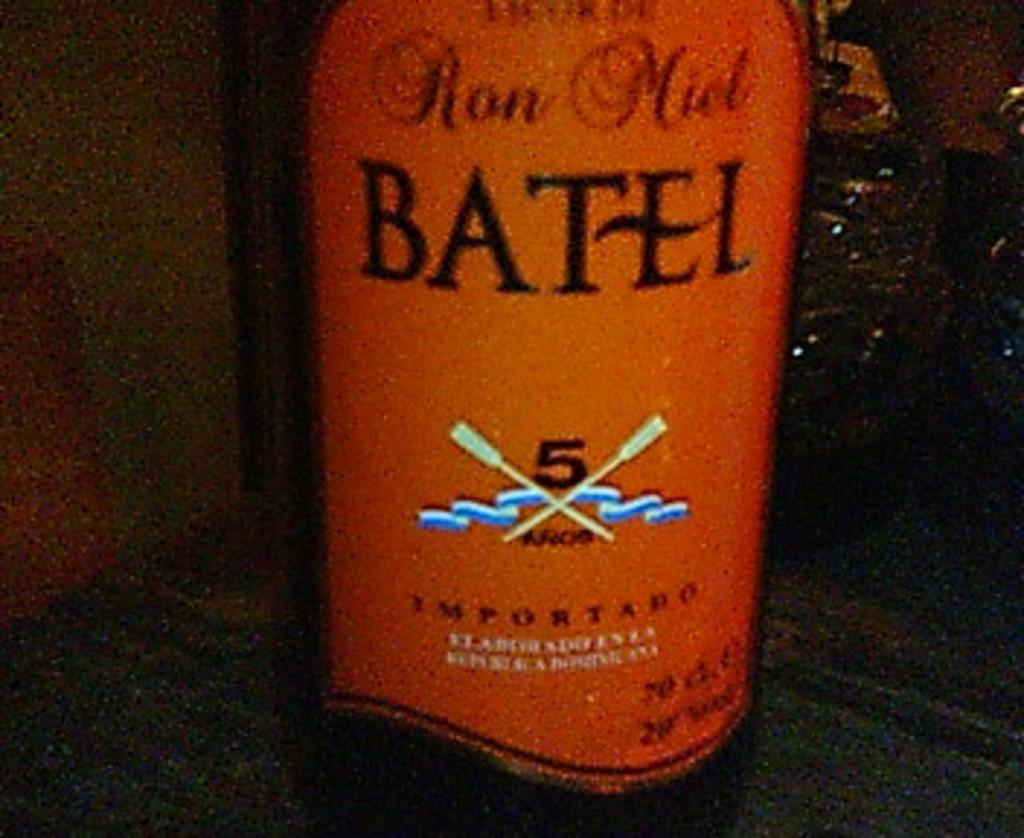What is the brand?
Your answer should be compact. Batel. Is this imported?
Provide a succinct answer. Yes. 